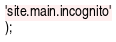Convert code to text. <code><loc_0><loc_0><loc_500><loc_500><_SQL_>'site.main.incognito'
);
</code> 